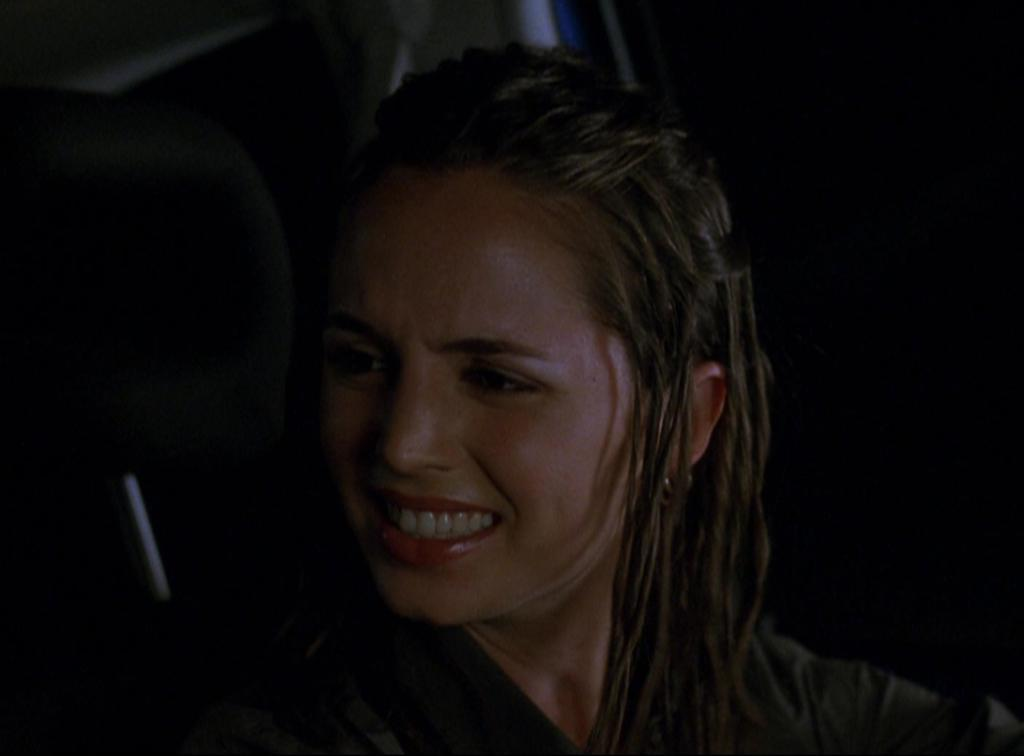What is the main subject of the image? The main subject of the image is a woman. Can you describe the background of the image? The background of the image is dark. What type of cart is visible in the image? There is no cart present in the image. What industry is depicted in the image? There is no industry depicted in the image. 